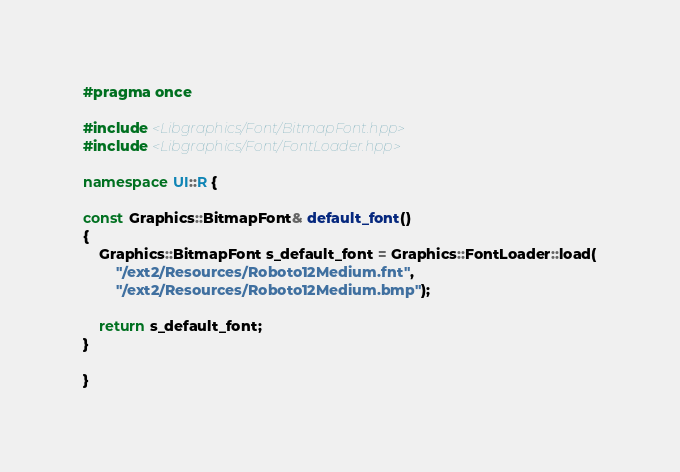Convert code to text. <code><loc_0><loc_0><loc_500><loc_500><_C++_>#pragma once

#include <Libgraphics/Font/BitmapFont.hpp>
#include <Libgraphics/Font/FontLoader.hpp>

namespace UI::R {

const Graphics::BitmapFont& default_font()
{
    Graphics::BitmapFont s_default_font = Graphics::FontLoader::load(
        "/ext2/Resources/Roboto12Medium.fnt",
        "/ext2/Resources/Roboto12Medium.bmp");

    return s_default_font;
}

}</code> 